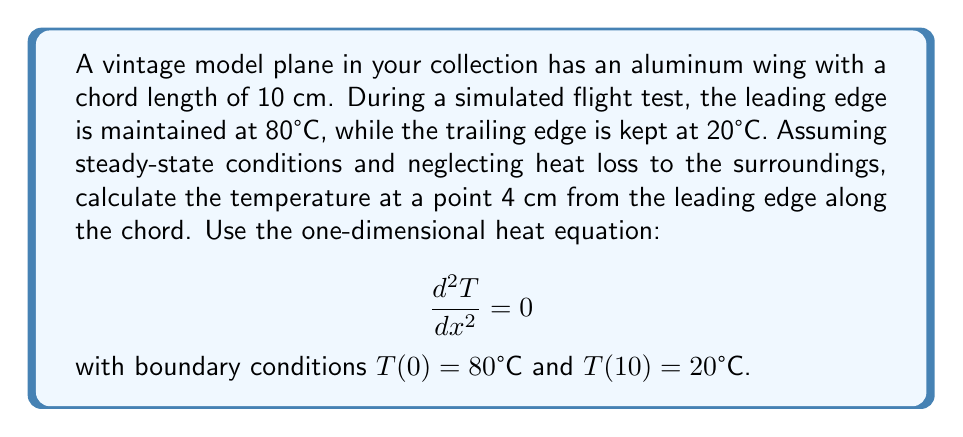Could you help me with this problem? 1) The general solution to the one-dimensional steady-state heat equation is:

   $$T(x) = ax + b$$

   where $a$ and $b$ are constants to be determined from the boundary conditions.

2) Apply the boundary conditions:
   At $x = 0$: $T(0) = 80 = b$
   At $x = 10$: $T(10) = 20 = 10a + b$

3) Substitute $b = 80$ into the second equation:
   $$20 = 10a + 80$$
   $$-60 = 10a$$
   $$a = -6$$

4) The temperature distribution along the wing chord is:
   $$T(x) = -6x + 80$$

5) To find the temperature at 4 cm from the leading edge, substitute $x = 4$:
   $$T(4) = -6(4) + 80 = -24 + 80 = 56°C$$
Answer: 56°C 